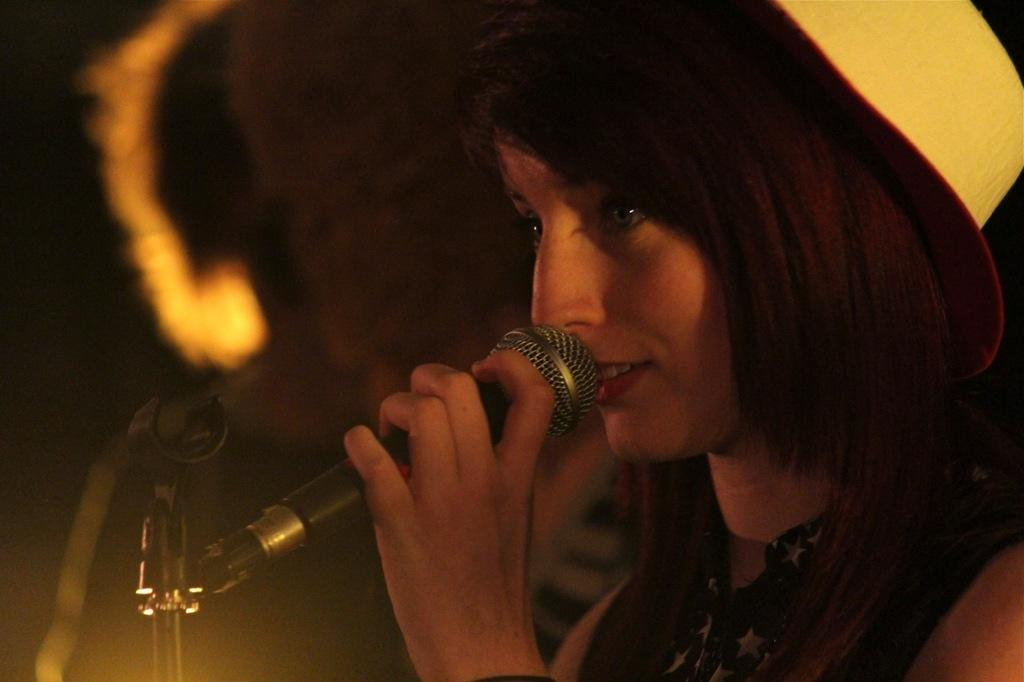Who is the main subject in the image? There is a woman in the image. Where is the woman positioned in the image? The woman is standing on the right side. What is the woman holding in the image? The woman is holding a microphone. How is the microphone positioned in relation to the woman? The microphone is positioned in front of her mouth. What can be inferred about the setting of the image? The image is taken on a stage, and the background is dark in color. What type of coat is the woman wearing in the image? There is no coat visible in the image; the woman is not wearing any outerwear. Can you see any plants in the background of the image? There are no plants present in the image; the background is dark and does not include any vegetation. 